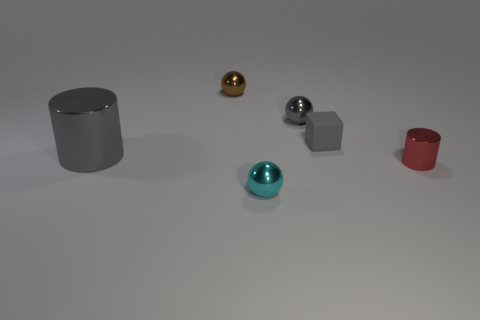How many shiny things are to the right of the brown sphere and in front of the tiny matte cube?
Your answer should be compact. 2. What number of red things are tiny metal things or small cylinders?
Your answer should be very brief. 1. What number of metal things are either tiny objects or green things?
Give a very brief answer. 4. Is there a small red cylinder?
Keep it short and to the point. Yes. Is the tiny brown object the same shape as the small red metallic object?
Your answer should be compact. No. There is a large gray cylinder that is behind the small shiny ball in front of the tiny gray rubber thing; what number of gray matte objects are right of it?
Provide a short and direct response. 1. There is a thing that is in front of the big gray metallic object and behind the cyan sphere; what is its material?
Your answer should be compact. Metal. What is the color of the tiny thing that is both left of the tiny gray matte cube and in front of the large shiny thing?
Keep it short and to the point. Cyan. Is there any other thing of the same color as the large cylinder?
Your answer should be very brief. Yes. There is a gray metal object that is on the right side of the metallic cylinder left of the ball that is left of the cyan metallic thing; what is its shape?
Give a very brief answer. Sphere. 